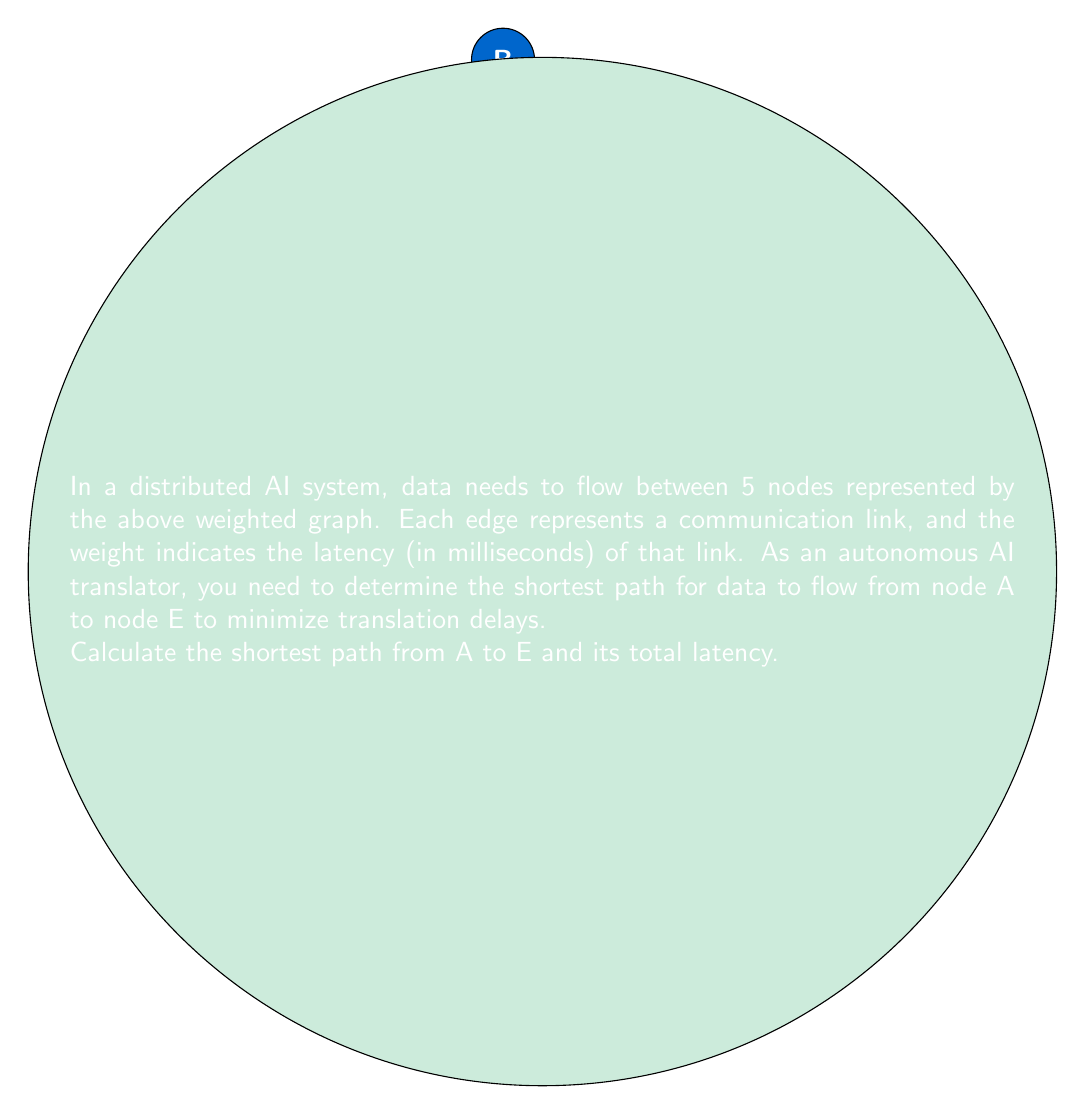Could you help me with this problem? To solve this problem, we'll use Dijkstra's algorithm to find the shortest path from node A to node E.

Step 1: Initialize distances
Set distance to A as 0 and all other nodes as infinity.
$d(A) = 0$, $d(B) = d(C) = d(D) = d(E) = \infty$

Step 2: Visit node A
Update distances:
$d(B) = 3$, $d(D) = 5$

Step 3: Visit node B (shortest unvisited)
Update distances:
$d(C) = 3 + 2 = 5$, $d(D) = \min(5, 3 + 1) = 4$

Step 4: Visit node D
Update distances:
$d(E) = 4 + 6 = 10$

Step 5: Visit node C
Update distances:
$d(E) = \min(10, 5 + 4) = 9$

Step 6: Visit node E
Algorithm complete. Shortest path found.

The shortest path is A → B → C → E with a total latency of 9 ms.

$$\text{Total Latency} = d(A,B) + d(B,C) + d(C,E) = 3 + 2 + 4 = 9 \text{ ms}$$
Answer: Path: A → B → C → E; Latency: 9 ms 